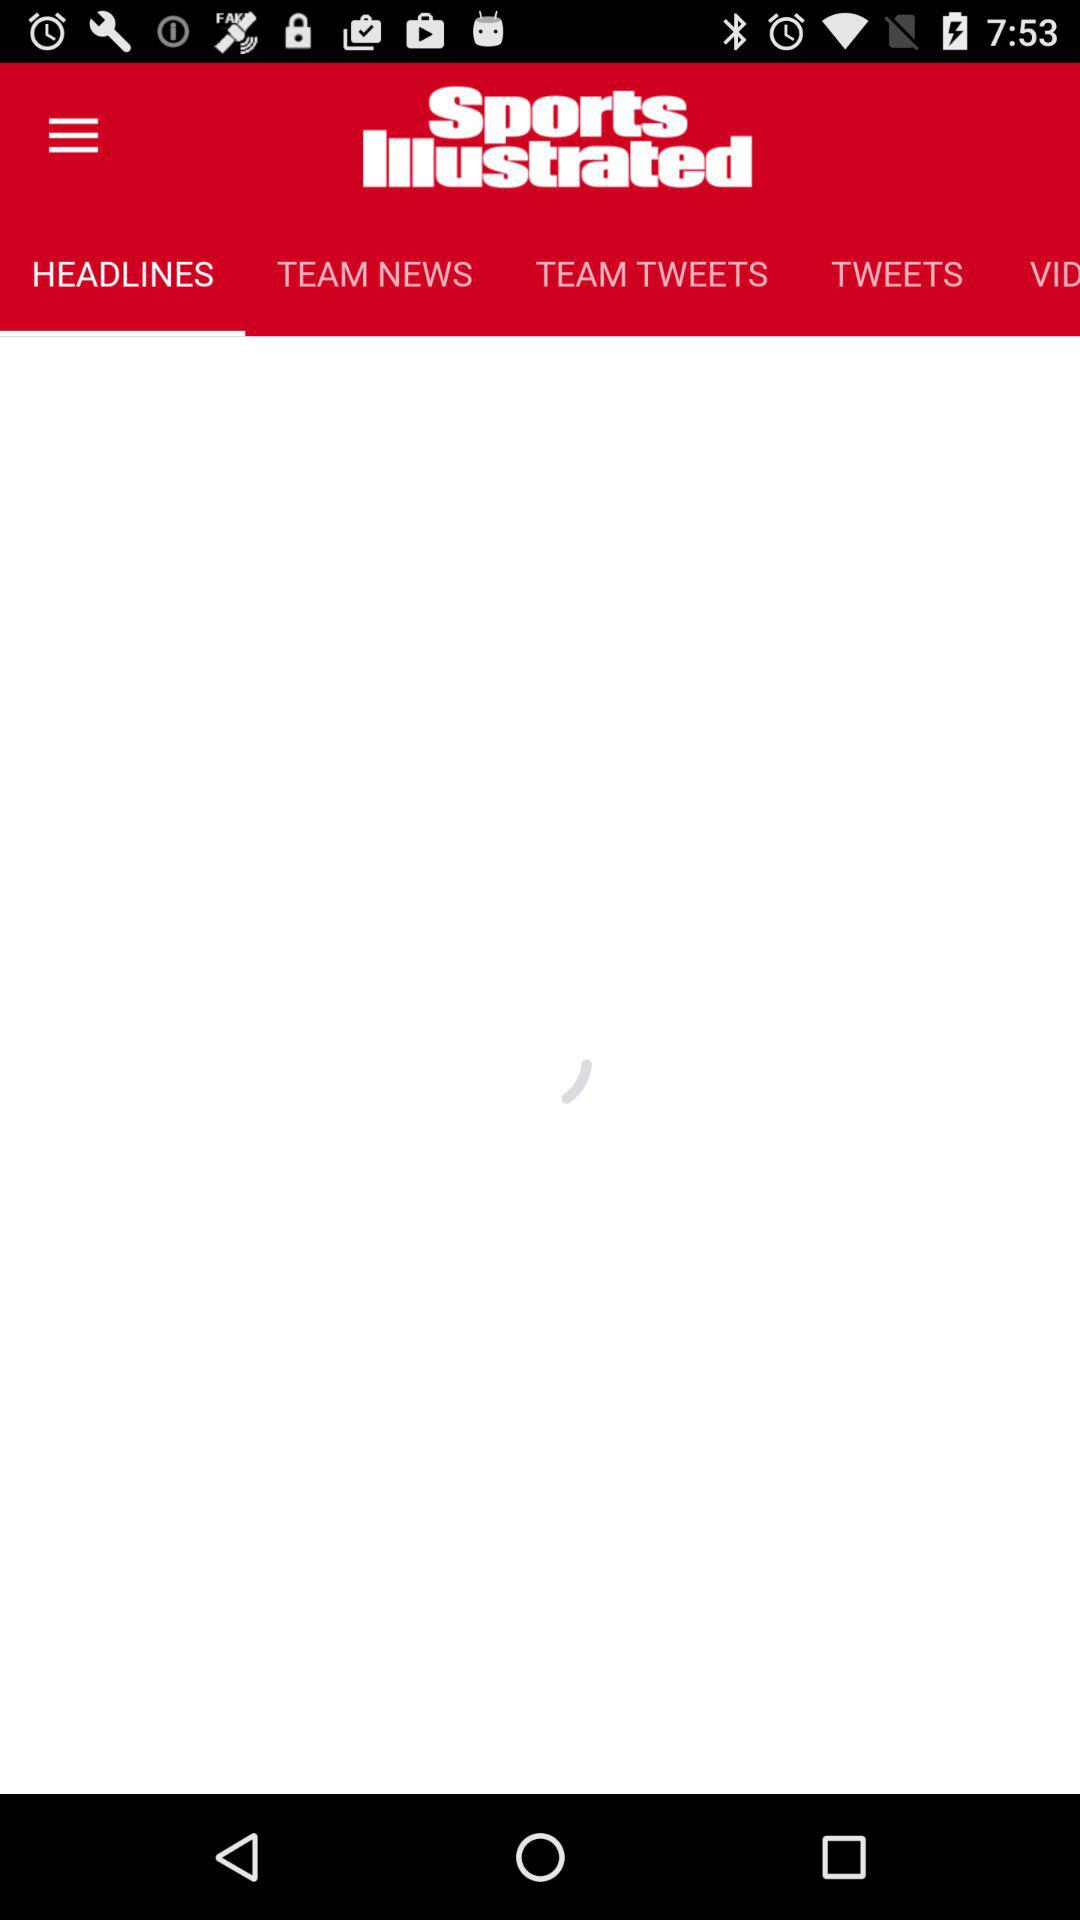Which tab is selected? The selected tab is "HEADLINES". 